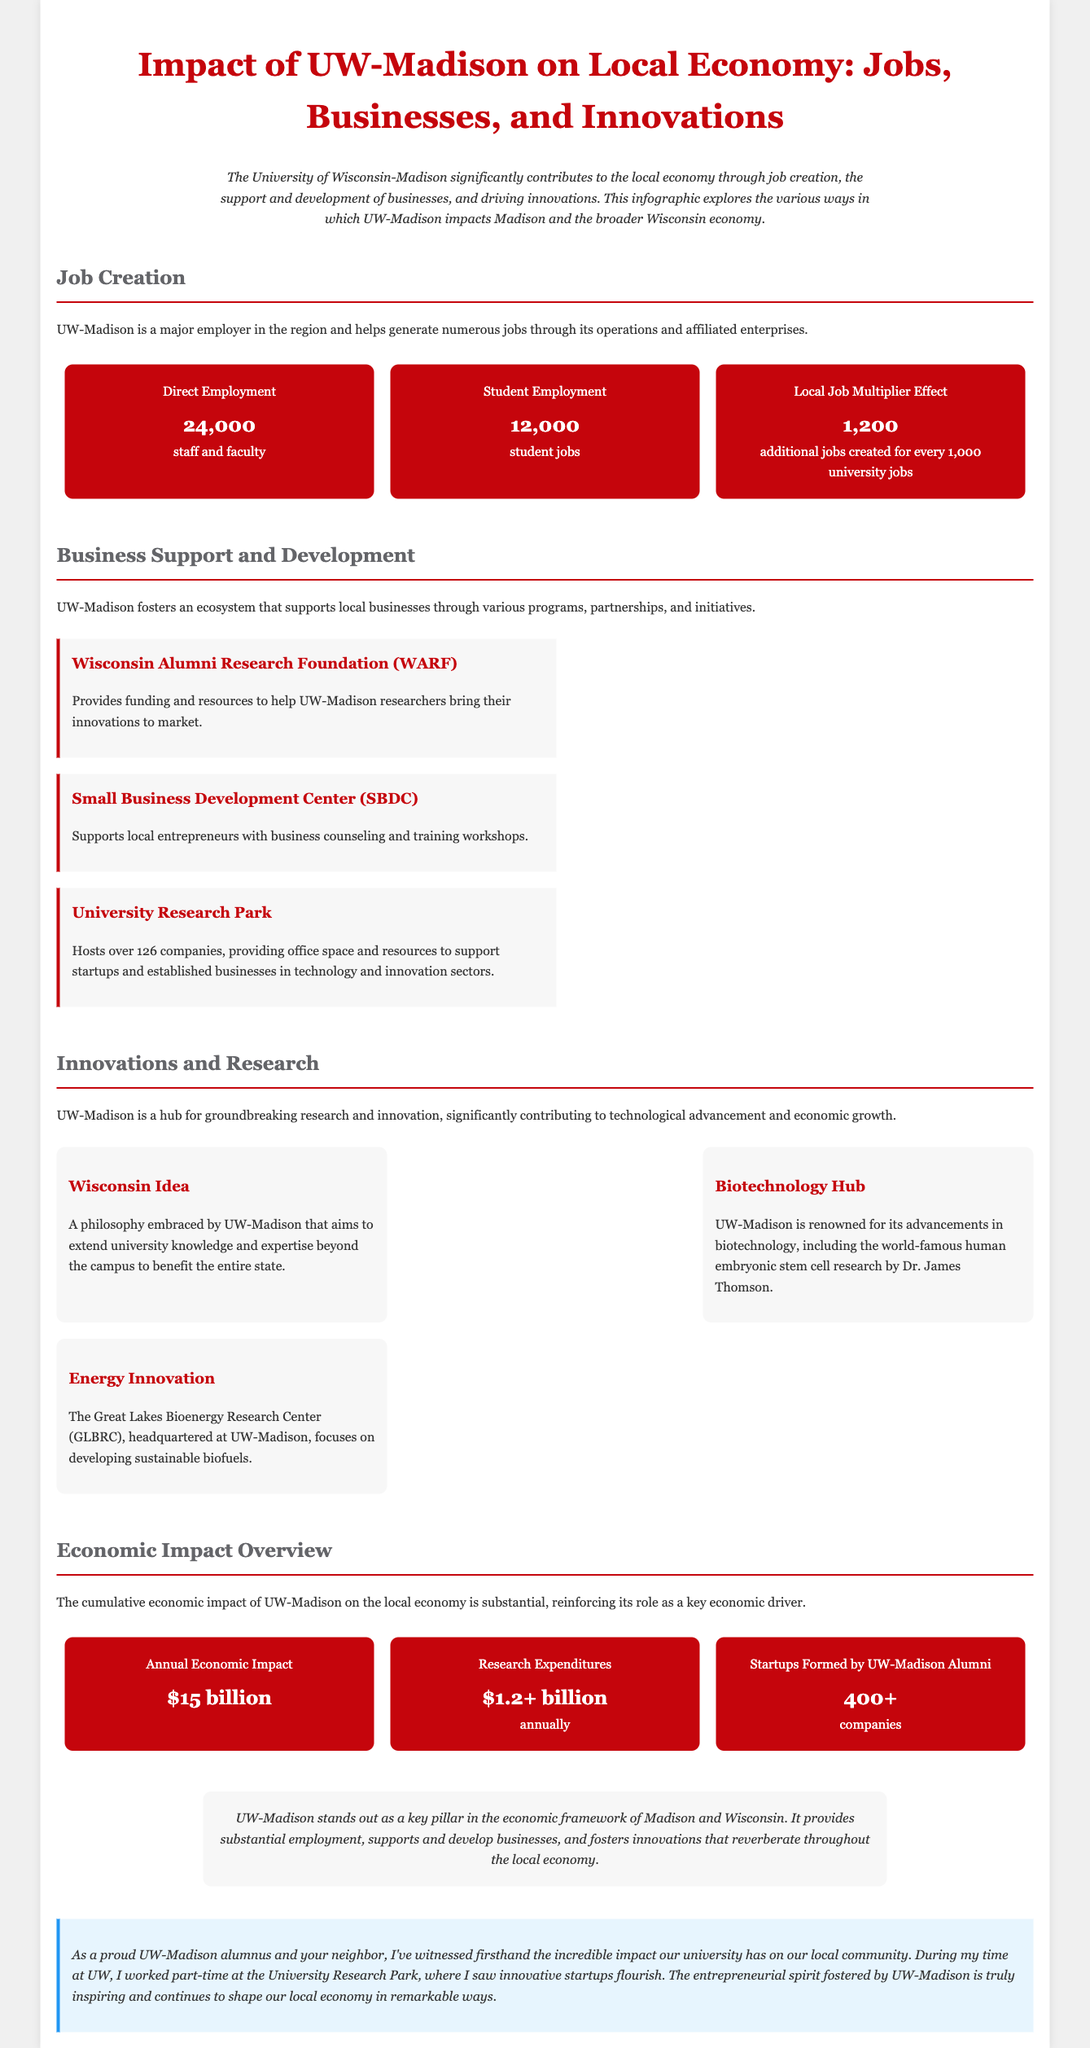what is the total number of direct employment at UW-Madison? The total number of direct employment is stated in the document as 24,000 staff and faculty.
Answer: 24,000 how many student jobs are there? The document specifies that there are 12,000 student jobs created through UW-Madison.
Answer: 12,000 what is the annual economic impact of UW-Madison? The document mentions the annual economic impact as $15 billion.
Answer: $15 billion how many additional jobs are created for every 1,000 university jobs? The document indicates that the local job multiplier effect creates 1,200 additional jobs for every 1,000 university jobs.
Answer: 1,200 what organization provides funding and resources to UW-Madison researchers? The Wisconsin Alumni Research Foundation (WARF) is responsible for providing funding and resources for researchers.
Answer: Wisconsin Alumni Research Foundation (WARF) what is the focus of the Great Lakes Bioenergy Research Center? The GLBRC is focused on developing sustainable biofuels, as noted in the document.
Answer: Developing sustainable biofuels how many startups have been formed by UW-Madison alumni? The document states that over 400 companies have been formed by UW-Madison alumni.
Answer: 400+ what is the philosophy embraced by UW-Madison to extend knowledge beyond campus? The document describes this as the "Wisconsin Idea."
Answer: Wisconsin Idea what type of support does the Small Business Development Center (SBDC) provide? The SBDC supports local entrepreneurs with business counseling and training workshops, as mentioned in the document.
Answer: Business counseling and training workshops 